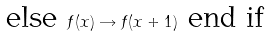Convert formula to latex. <formula><loc_0><loc_0><loc_500><loc_500>\text {else } f ( x ) \rightarrow f ( x + 1 ) \text { end if}</formula> 